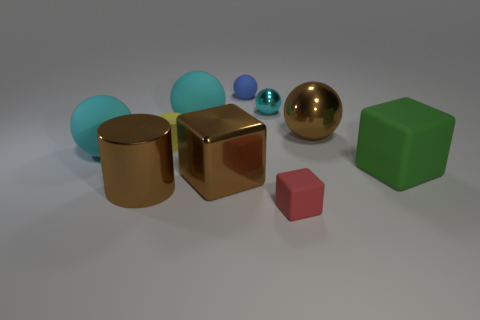The big metallic cube is what color?
Offer a very short reply. Brown. What number of small yellow metallic cylinders are there?
Make the answer very short. 0. What number of big metal cubes are the same color as the tiny matte cylinder?
Provide a short and direct response. 0. Is the shape of the tiny thing that is behind the tiny cyan metallic sphere the same as the cyan object that is to the right of the small rubber sphere?
Offer a terse response. Yes. The metallic ball that is behind the big rubber ball behind the big cyan thing in front of the tiny cylinder is what color?
Offer a very short reply. Cyan. There is a big metal thing that is to the left of the shiny cube; what color is it?
Provide a succinct answer. Brown. There is a matte cylinder that is the same size as the blue matte thing; what color is it?
Keep it short and to the point. Yellow. Do the yellow matte object and the red matte object have the same size?
Give a very brief answer. Yes. There is a yellow rubber thing; how many shiny objects are on the left side of it?
Your answer should be compact. 1. How many objects are either large shiny things that are behind the large green cube or big cyan matte spheres?
Provide a short and direct response. 3. 